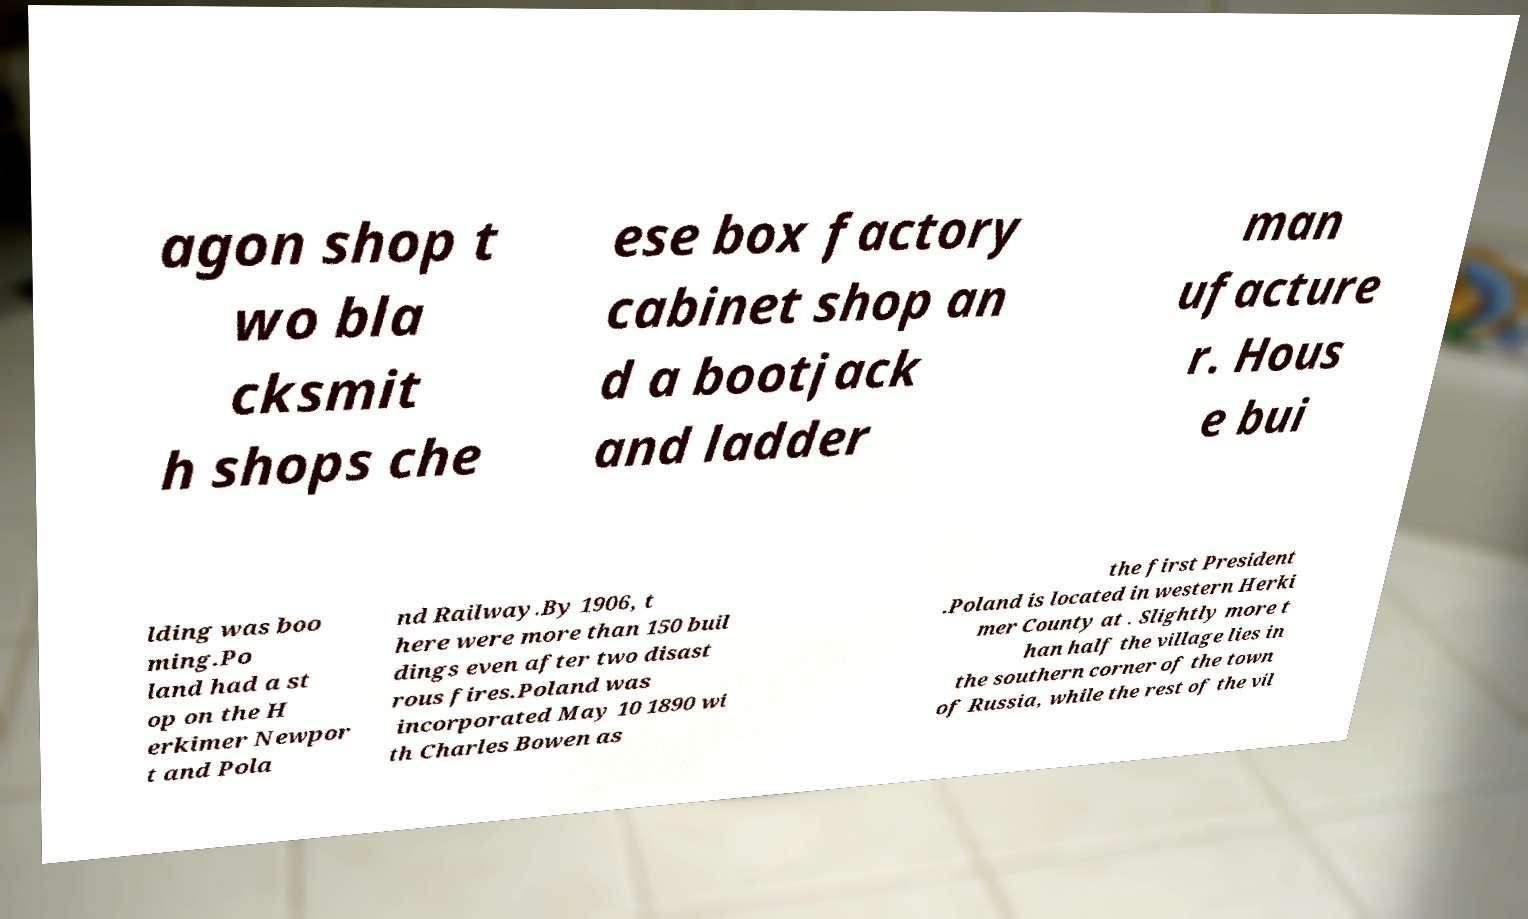Could you assist in decoding the text presented in this image and type it out clearly? agon shop t wo bla cksmit h shops che ese box factory cabinet shop an d a bootjack and ladder man ufacture r. Hous e bui lding was boo ming.Po land had a st op on the H erkimer Newpor t and Pola nd Railway.By 1906, t here were more than 150 buil dings even after two disast rous fires.Poland was incorporated May 10 1890 wi th Charles Bowen as the first President .Poland is located in western Herki mer County at . Slightly more t han half the village lies in the southern corner of the town of Russia, while the rest of the vil 